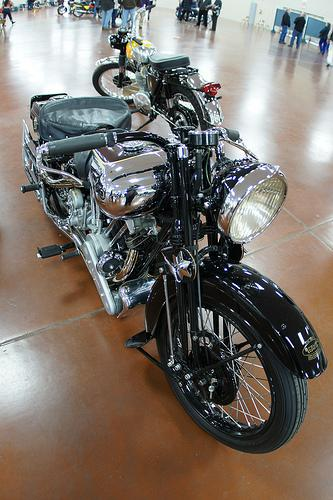Question: where is this scene?
Choices:
A. Beach.
B. On Yacht.
C. Park.
D. Inside a building.
Answer with the letter. Answer: D Question: where are more motorcycles?
Choices:
A. In parking lot.
B. On the road.
C. In the showroom.
D. Towards the back of the room.
Answer with the letter. Answer: D Question: where is the light?
Choices:
A. On table.
B. Overhead.
C. On the corner.
D. On the front of the motorcycle.
Answer with the letter. Answer: D Question: what kind of motorcycle is this?
Choices:
A. Indian.
B. A one seater.
C. Harley.
D. Crotch rocket.
Answer with the letter. Answer: B Question: how is the motorcycle standing?
Choices:
A. Someone is supporting it.
B. A stand.
C. A kickstand.
D. It's leaning against something.
Answer with the letter. Answer: C 